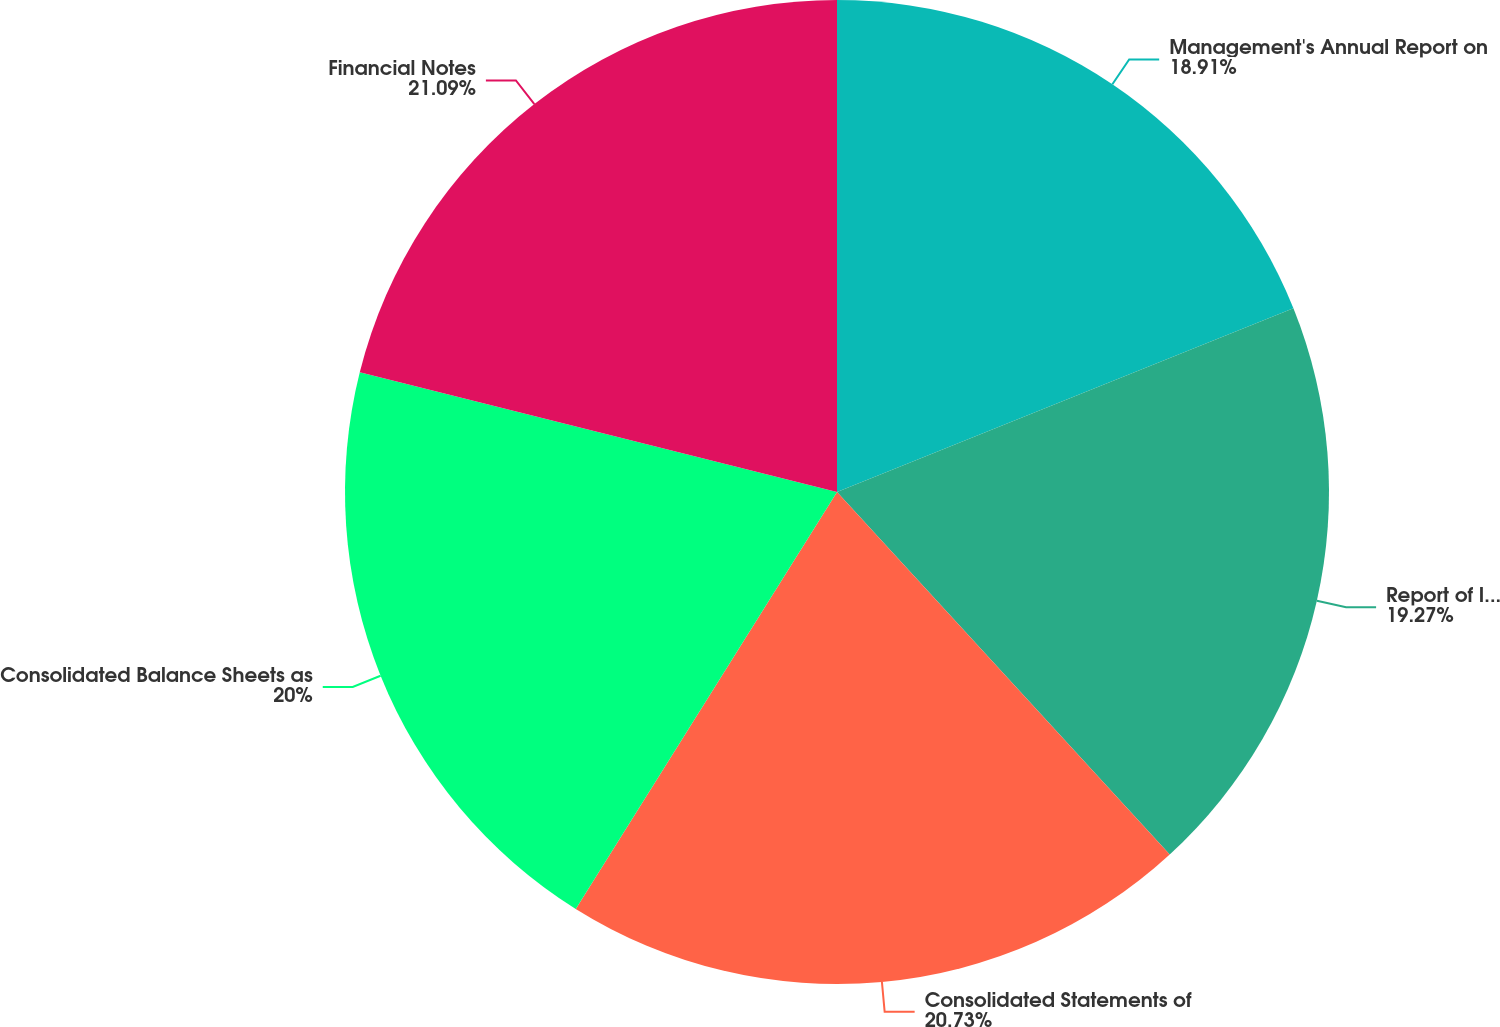<chart> <loc_0><loc_0><loc_500><loc_500><pie_chart><fcel>Management's Annual Report on<fcel>Report of Independent<fcel>Consolidated Statements of<fcel>Consolidated Balance Sheets as<fcel>Financial Notes<nl><fcel>18.91%<fcel>19.27%<fcel>20.73%<fcel>20.0%<fcel>21.09%<nl></chart> 